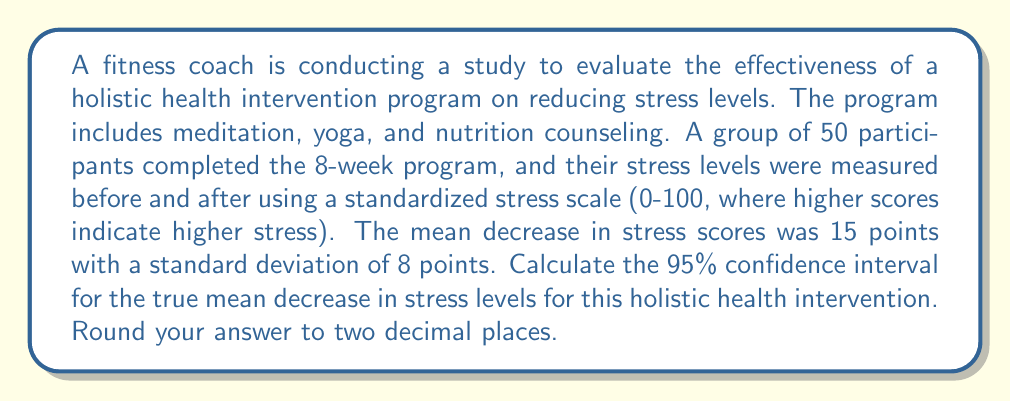Could you help me with this problem? To calculate the confidence interval, we'll use the formula:

$$ CI = \bar{x} \pm t_{\alpha/2} \cdot \frac{s}{\sqrt{n}} $$

Where:
$\bar{x}$ = sample mean (15 points)
$s$ = sample standard deviation (8 points)
$n$ = sample size (50)
$t_{\alpha/2}$ = t-value for 95% confidence interval with 49 degrees of freedom

Steps:
1) Find the t-value:
   With 49 degrees of freedom (n-1) and 95% confidence, $t_{\alpha/2} = 2.010$ (from t-distribution table)

2) Calculate the standard error of the mean (SEM):
   $SEM = \frac{s}{\sqrt{n}} = \frac{8}{\sqrt{50}} = 1.131$

3) Calculate the margin of error:
   $Margin of Error = t_{\alpha/2} \cdot SEM = 2.010 \cdot 1.131 = 2.274$

4) Calculate the confidence interval:
   $CI = 15 \pm 2.274$
   
   Lower bound: $15 - 2.274 = 12.726$
   Upper bound: $15 + 2.274 = 17.274$

5) Round to two decimal places:
   $CI = (12.73, 17.27)$
Answer: The 95% confidence interval for the true mean decrease in stress levels is (12.73, 17.27) points. 